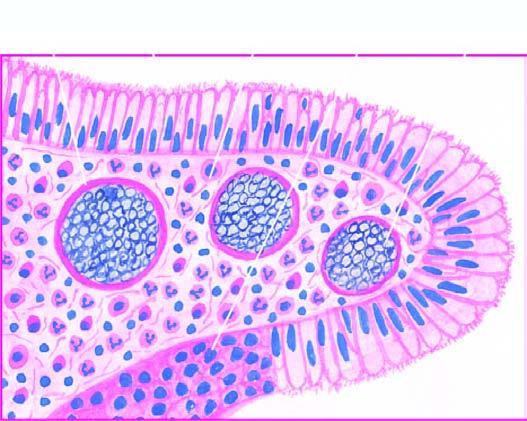re remodelled bone ends ; the external callus present in sporangia as well as are intermingled in the inflammatory cell infiltrate?
Answer the question using a single word or phrase. No 